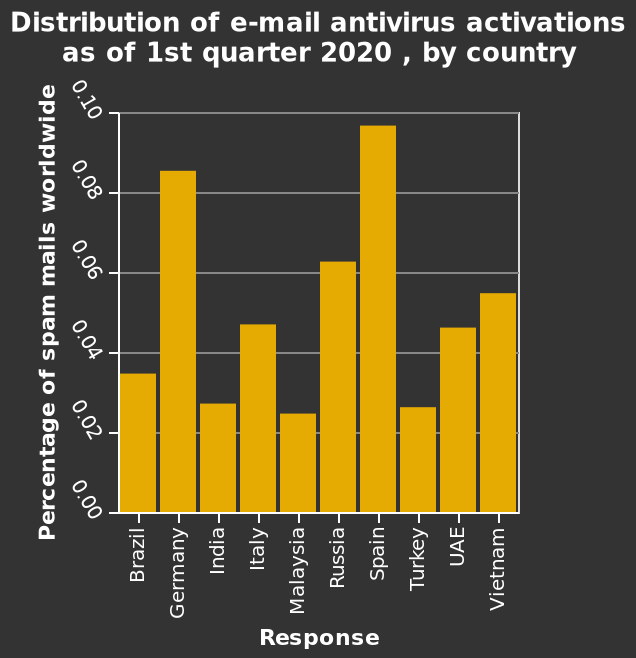<image>
How would you describe the variation in the bar chart?  The bar chart shows a lot of variation. What does the x-axis measure in this bar plot?  The x-axis measures the response. What is the timeframe of the data presented in this bar plot? The data presented in this bar plot is for the 1st quarter of 2020. 